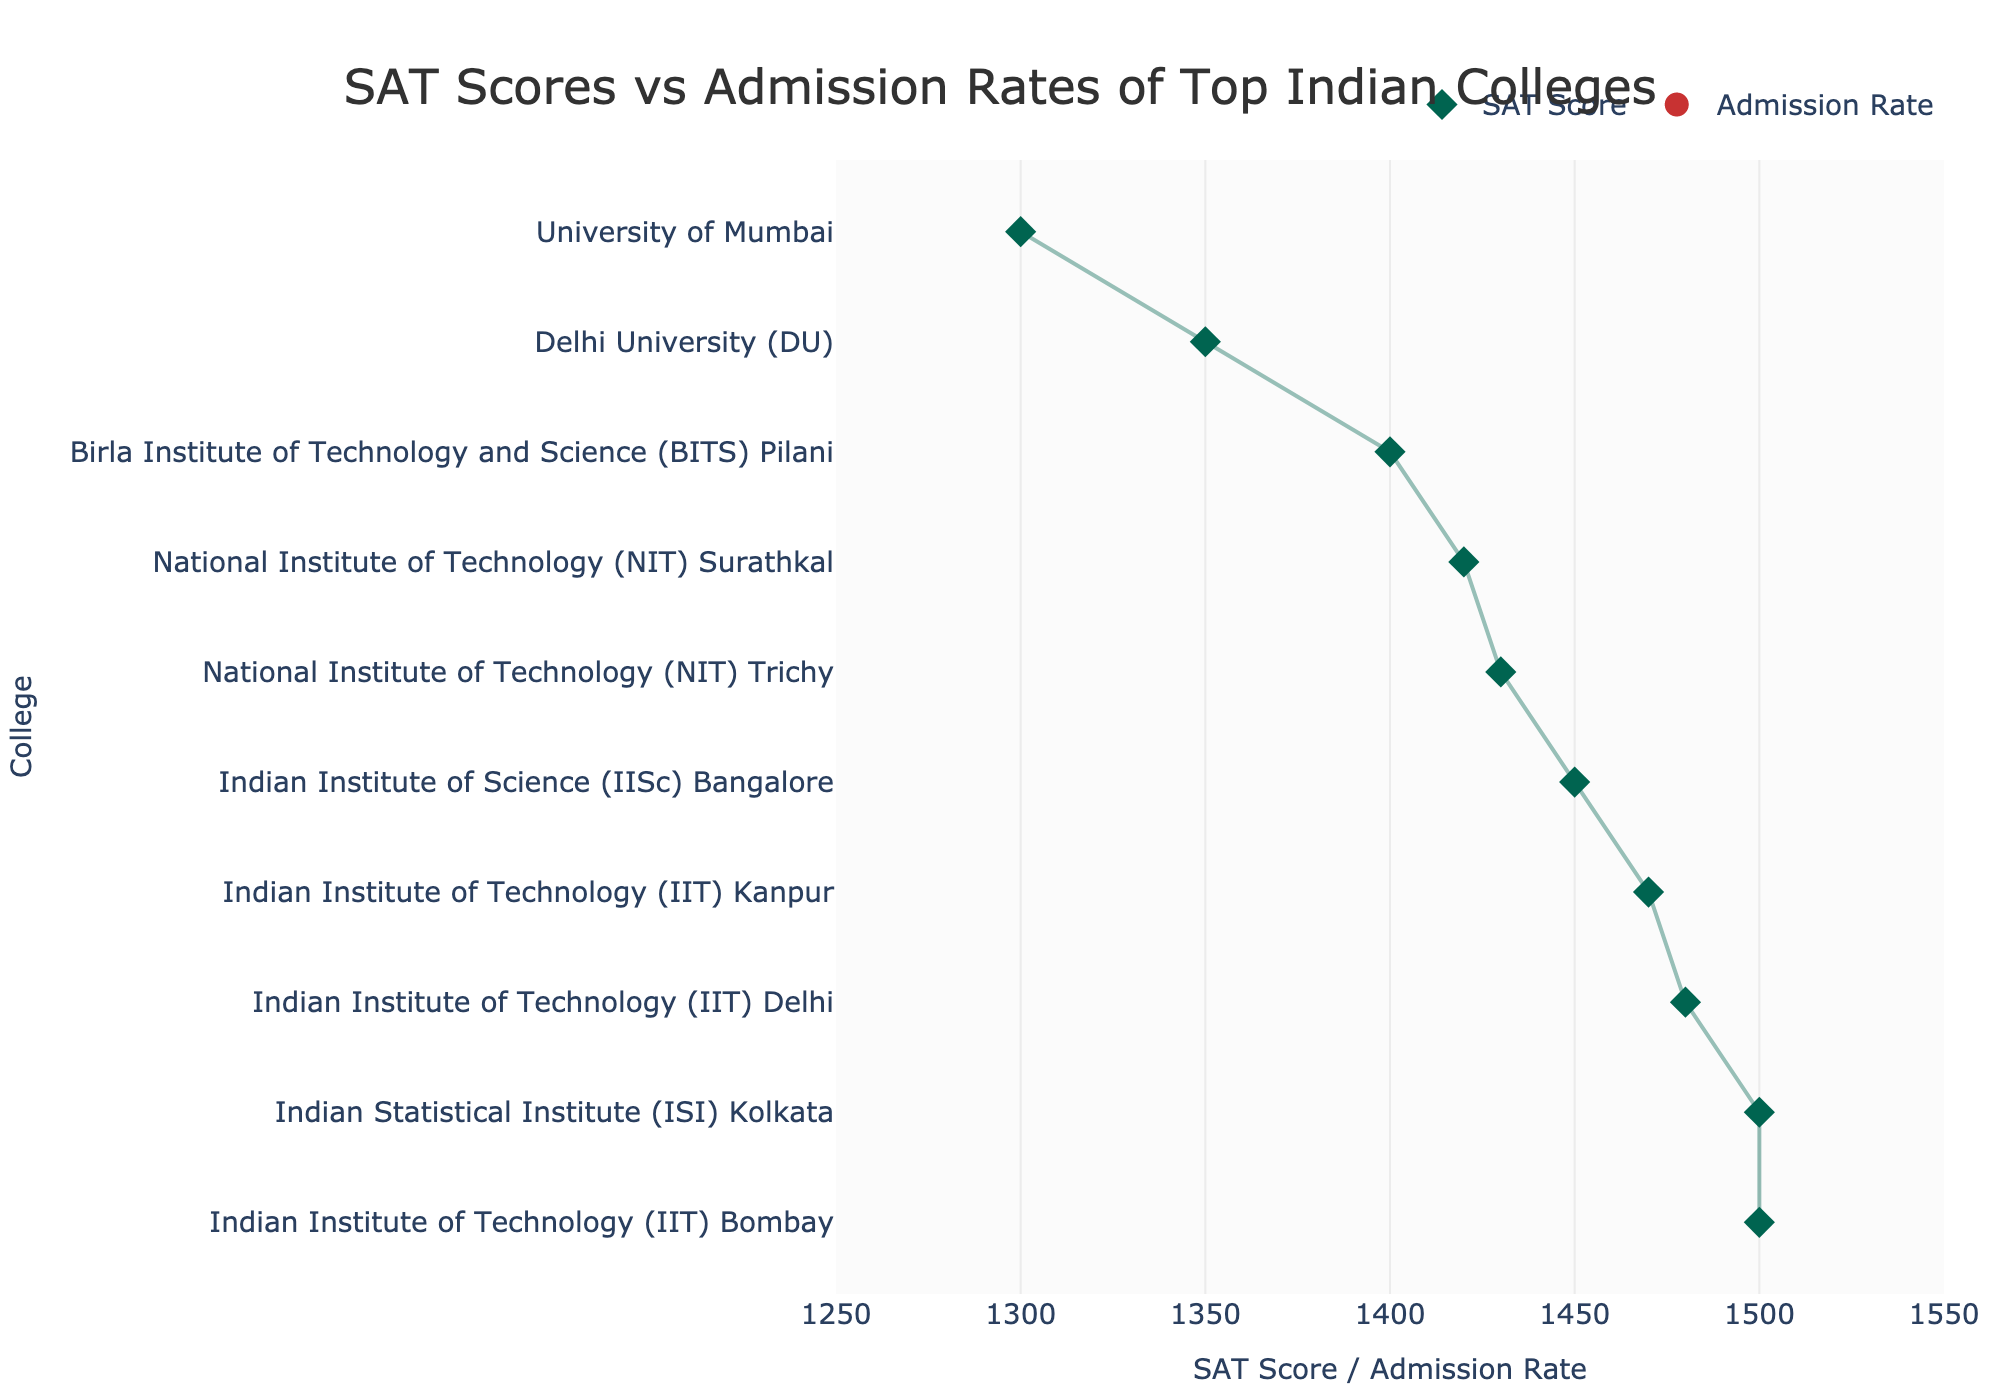Which college has the highest average SAT score? The highest SAT score is represented by the first marker on the plot where its SAT score is highest. The college with the highest average SAT score is at the top position.
Answer: Indian Statistical Institute (ISI) Kolkata What's the average admission rate of IIT Bombay? Look at IIT Bombay and find the admission rate marker, then compare it with the secondary x-axis on top which shows admission rate in percentage. IIT Bombay's admission rate marker points to around 0.073.
Answer: 7.3% Which college has both the lowest average SAT score and the highest average admission rate? Look for the college at the lowest position in the plot and check its SAT score and then compare its admission rate with others. The lowest SAT score marker is around 1300 and the highest admission rate marker is around 18%, confirmed by the plot.
Answer: University of Mumbai How does the average SAT score of IIT Kanpur compare to IISc Bangalore? Locate the markers for IIT Kanpur and IISc Bangalore for SAT scores and compare. IIT Kanpur is a bit higher than IISc Bangalore.
Answer: IIT Kanpur's SAT score is higher What is the range of SAT scores for the colleges shown in the plot? Check the highest and lowest SAT scores represented by the leftmost and rightmost markers along the x-axis. The highest is 1500 and the lowest is 1300.
Answer: 1300 to 1500 Between BITS Pilani and NIT Surathkal, which has a higher admission rate? Compare the admission rate markers of BITS Pilani and NIT Surathkal. The marker for BITS Pilani is slightly higher on the secondary x-axis than NIT Surathkal’s marker.
Answer: BITS Pilani Which college has a nearly identical average SAT score as ISI Kolkata but much lower average admission rate? Check for colleges with close or identical SAT scores to ISI Kolkata but compare their admission rates, finding that IIT Bombay has the same SAT score but lower admission rate.
Answer: IIT Bombay How many colleges have an average admission rate of 12% or higher? Locate the markers on the secondary x-axis with admission rates equal to or higher than 12%, and count them. There are three markers.
Answer: Three colleges What's the difference in average admission rates between the highest and lowest rated IITs on the chart? Identify the admission rate markers for the highest and lowest rated IITs and calculate the difference: IIT Bombay (7.3%) and IIT Kanpur (8.4%).
Answer: 1.1% How are the markers for SAT scores and admission rates of colleges differentiated visually? Observe the plot's legend and the marker shapes/colors: SAT scores use diamond-shaped markers in green, while admission rates use circle-shaped markers in red.
Answer: Different shapes and colors 